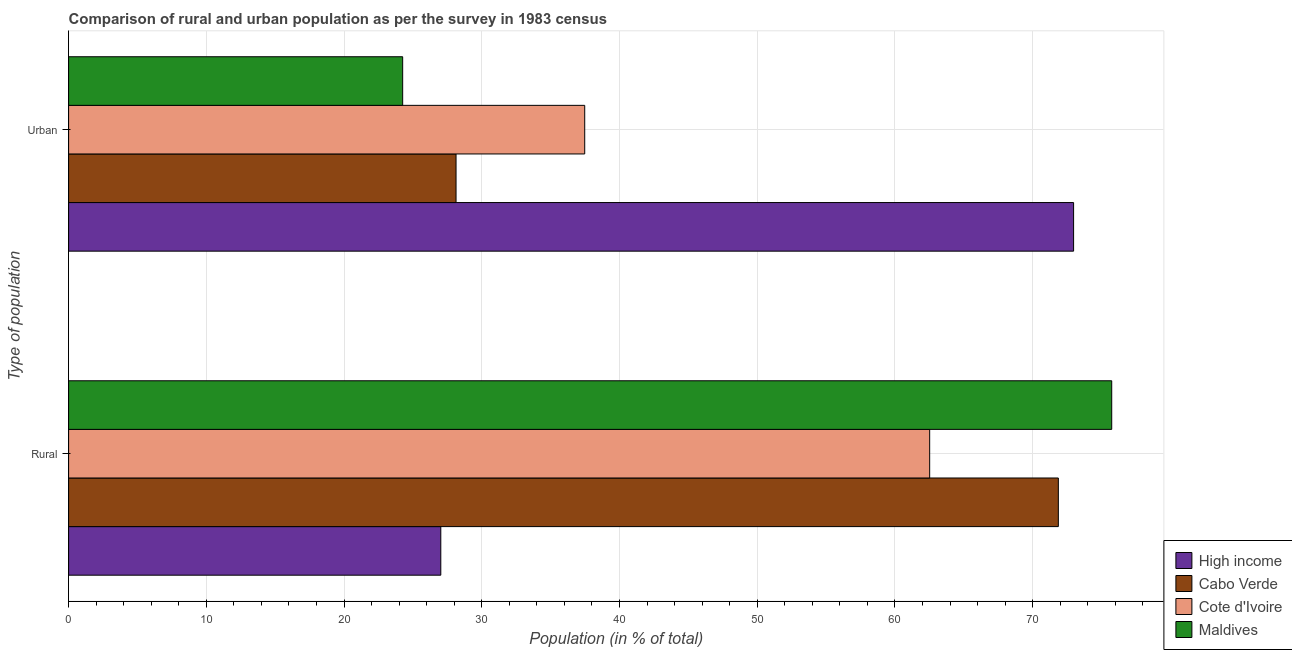How many different coloured bars are there?
Offer a terse response. 4. Are the number of bars on each tick of the Y-axis equal?
Give a very brief answer. Yes. How many bars are there on the 1st tick from the top?
Offer a terse response. 4. How many bars are there on the 1st tick from the bottom?
Make the answer very short. 4. What is the label of the 1st group of bars from the top?
Give a very brief answer. Urban. What is the rural population in Maldives?
Your response must be concise. 75.74. Across all countries, what is the maximum urban population?
Offer a terse response. 72.97. Across all countries, what is the minimum urban population?
Keep it short and to the point. 24.26. What is the total urban population in the graph?
Your response must be concise. 162.84. What is the difference between the rural population in Cabo Verde and that in Cote d'Ivoire?
Provide a short and direct response. 9.34. What is the difference between the rural population in Cote d'Ivoire and the urban population in Maldives?
Provide a short and direct response. 38.27. What is the average urban population per country?
Make the answer very short. 40.71. What is the difference between the urban population and rural population in Cabo Verde?
Your answer should be very brief. -43.73. In how many countries, is the rural population greater than 16 %?
Make the answer very short. 4. What is the ratio of the rural population in High income to that in Cote d'Ivoire?
Ensure brevity in your answer.  0.43. In how many countries, is the urban population greater than the average urban population taken over all countries?
Your response must be concise. 1. What does the 1st bar from the top in Rural represents?
Your response must be concise. Maldives. What does the 1st bar from the bottom in Urban represents?
Provide a short and direct response. High income. Are all the bars in the graph horizontal?
Your answer should be very brief. Yes. What is the difference between two consecutive major ticks on the X-axis?
Make the answer very short. 10. Are the values on the major ticks of X-axis written in scientific E-notation?
Make the answer very short. No. Does the graph contain any zero values?
Offer a terse response. No. Where does the legend appear in the graph?
Your answer should be very brief. Bottom right. What is the title of the graph?
Ensure brevity in your answer.  Comparison of rural and urban population as per the survey in 1983 census. What is the label or title of the X-axis?
Provide a succinct answer. Population (in % of total). What is the label or title of the Y-axis?
Make the answer very short. Type of population. What is the Population (in % of total) of High income in Rural?
Give a very brief answer. 27.03. What is the Population (in % of total) in Cabo Verde in Rural?
Make the answer very short. 71.87. What is the Population (in % of total) of Cote d'Ivoire in Rural?
Offer a terse response. 62.52. What is the Population (in % of total) of Maldives in Rural?
Provide a succinct answer. 75.74. What is the Population (in % of total) in High income in Urban?
Offer a very short reply. 72.97. What is the Population (in % of total) of Cabo Verde in Urban?
Your answer should be very brief. 28.13. What is the Population (in % of total) of Cote d'Ivoire in Urban?
Offer a very short reply. 37.48. What is the Population (in % of total) of Maldives in Urban?
Offer a very short reply. 24.26. Across all Type of population, what is the maximum Population (in % of total) in High income?
Provide a succinct answer. 72.97. Across all Type of population, what is the maximum Population (in % of total) of Cabo Verde?
Give a very brief answer. 71.87. Across all Type of population, what is the maximum Population (in % of total) of Cote d'Ivoire?
Your answer should be very brief. 62.52. Across all Type of population, what is the maximum Population (in % of total) in Maldives?
Offer a terse response. 75.74. Across all Type of population, what is the minimum Population (in % of total) of High income?
Offer a very short reply. 27.03. Across all Type of population, what is the minimum Population (in % of total) of Cabo Verde?
Your answer should be compact. 28.13. Across all Type of population, what is the minimum Population (in % of total) in Cote d'Ivoire?
Offer a very short reply. 37.48. Across all Type of population, what is the minimum Population (in % of total) of Maldives?
Your answer should be compact. 24.26. What is the total Population (in % of total) of High income in the graph?
Your answer should be very brief. 100. What is the total Population (in % of total) in Cabo Verde in the graph?
Provide a short and direct response. 100. What is the total Population (in % of total) in Cote d'Ivoire in the graph?
Keep it short and to the point. 100. What is the total Population (in % of total) of Maldives in the graph?
Your response must be concise. 100. What is the difference between the Population (in % of total) of High income in Rural and that in Urban?
Offer a very short reply. -45.95. What is the difference between the Population (in % of total) in Cabo Verde in Rural and that in Urban?
Your response must be concise. 43.73. What is the difference between the Population (in % of total) of Cote d'Ivoire in Rural and that in Urban?
Keep it short and to the point. 25.05. What is the difference between the Population (in % of total) in Maldives in Rural and that in Urban?
Keep it short and to the point. 51.49. What is the difference between the Population (in % of total) in High income in Rural and the Population (in % of total) in Cabo Verde in Urban?
Give a very brief answer. -1.11. What is the difference between the Population (in % of total) in High income in Rural and the Population (in % of total) in Cote d'Ivoire in Urban?
Ensure brevity in your answer.  -10.45. What is the difference between the Population (in % of total) of High income in Rural and the Population (in % of total) of Maldives in Urban?
Give a very brief answer. 2.77. What is the difference between the Population (in % of total) of Cabo Verde in Rural and the Population (in % of total) of Cote d'Ivoire in Urban?
Offer a very short reply. 34.39. What is the difference between the Population (in % of total) in Cabo Verde in Rural and the Population (in % of total) in Maldives in Urban?
Provide a short and direct response. 47.61. What is the difference between the Population (in % of total) of Cote d'Ivoire in Rural and the Population (in % of total) of Maldives in Urban?
Provide a succinct answer. 38.27. What is the average Population (in % of total) in Cote d'Ivoire per Type of population?
Make the answer very short. 50. What is the difference between the Population (in % of total) in High income and Population (in % of total) in Cabo Verde in Rural?
Offer a terse response. -44.84. What is the difference between the Population (in % of total) of High income and Population (in % of total) of Cote d'Ivoire in Rural?
Give a very brief answer. -35.5. What is the difference between the Population (in % of total) of High income and Population (in % of total) of Maldives in Rural?
Provide a short and direct response. -48.72. What is the difference between the Population (in % of total) in Cabo Verde and Population (in % of total) in Cote d'Ivoire in Rural?
Provide a short and direct response. 9.34. What is the difference between the Population (in % of total) in Cabo Verde and Population (in % of total) in Maldives in Rural?
Keep it short and to the point. -3.88. What is the difference between the Population (in % of total) in Cote d'Ivoire and Population (in % of total) in Maldives in Rural?
Offer a very short reply. -13.22. What is the difference between the Population (in % of total) of High income and Population (in % of total) of Cabo Verde in Urban?
Your response must be concise. 44.84. What is the difference between the Population (in % of total) of High income and Population (in % of total) of Cote d'Ivoire in Urban?
Make the answer very short. 35.5. What is the difference between the Population (in % of total) in High income and Population (in % of total) in Maldives in Urban?
Offer a very short reply. 48.72. What is the difference between the Population (in % of total) of Cabo Verde and Population (in % of total) of Cote d'Ivoire in Urban?
Give a very brief answer. -9.34. What is the difference between the Population (in % of total) of Cabo Verde and Population (in % of total) of Maldives in Urban?
Offer a very short reply. 3.88. What is the difference between the Population (in % of total) in Cote d'Ivoire and Population (in % of total) in Maldives in Urban?
Ensure brevity in your answer.  13.22. What is the ratio of the Population (in % of total) of High income in Rural to that in Urban?
Make the answer very short. 0.37. What is the ratio of the Population (in % of total) in Cabo Verde in Rural to that in Urban?
Your answer should be compact. 2.55. What is the ratio of the Population (in % of total) in Cote d'Ivoire in Rural to that in Urban?
Provide a short and direct response. 1.67. What is the ratio of the Population (in % of total) in Maldives in Rural to that in Urban?
Provide a succinct answer. 3.12. What is the difference between the highest and the second highest Population (in % of total) in High income?
Keep it short and to the point. 45.95. What is the difference between the highest and the second highest Population (in % of total) of Cabo Verde?
Keep it short and to the point. 43.73. What is the difference between the highest and the second highest Population (in % of total) in Cote d'Ivoire?
Keep it short and to the point. 25.05. What is the difference between the highest and the second highest Population (in % of total) of Maldives?
Offer a terse response. 51.49. What is the difference between the highest and the lowest Population (in % of total) of High income?
Your response must be concise. 45.95. What is the difference between the highest and the lowest Population (in % of total) of Cabo Verde?
Provide a short and direct response. 43.73. What is the difference between the highest and the lowest Population (in % of total) of Cote d'Ivoire?
Your answer should be compact. 25.05. What is the difference between the highest and the lowest Population (in % of total) in Maldives?
Your answer should be very brief. 51.49. 